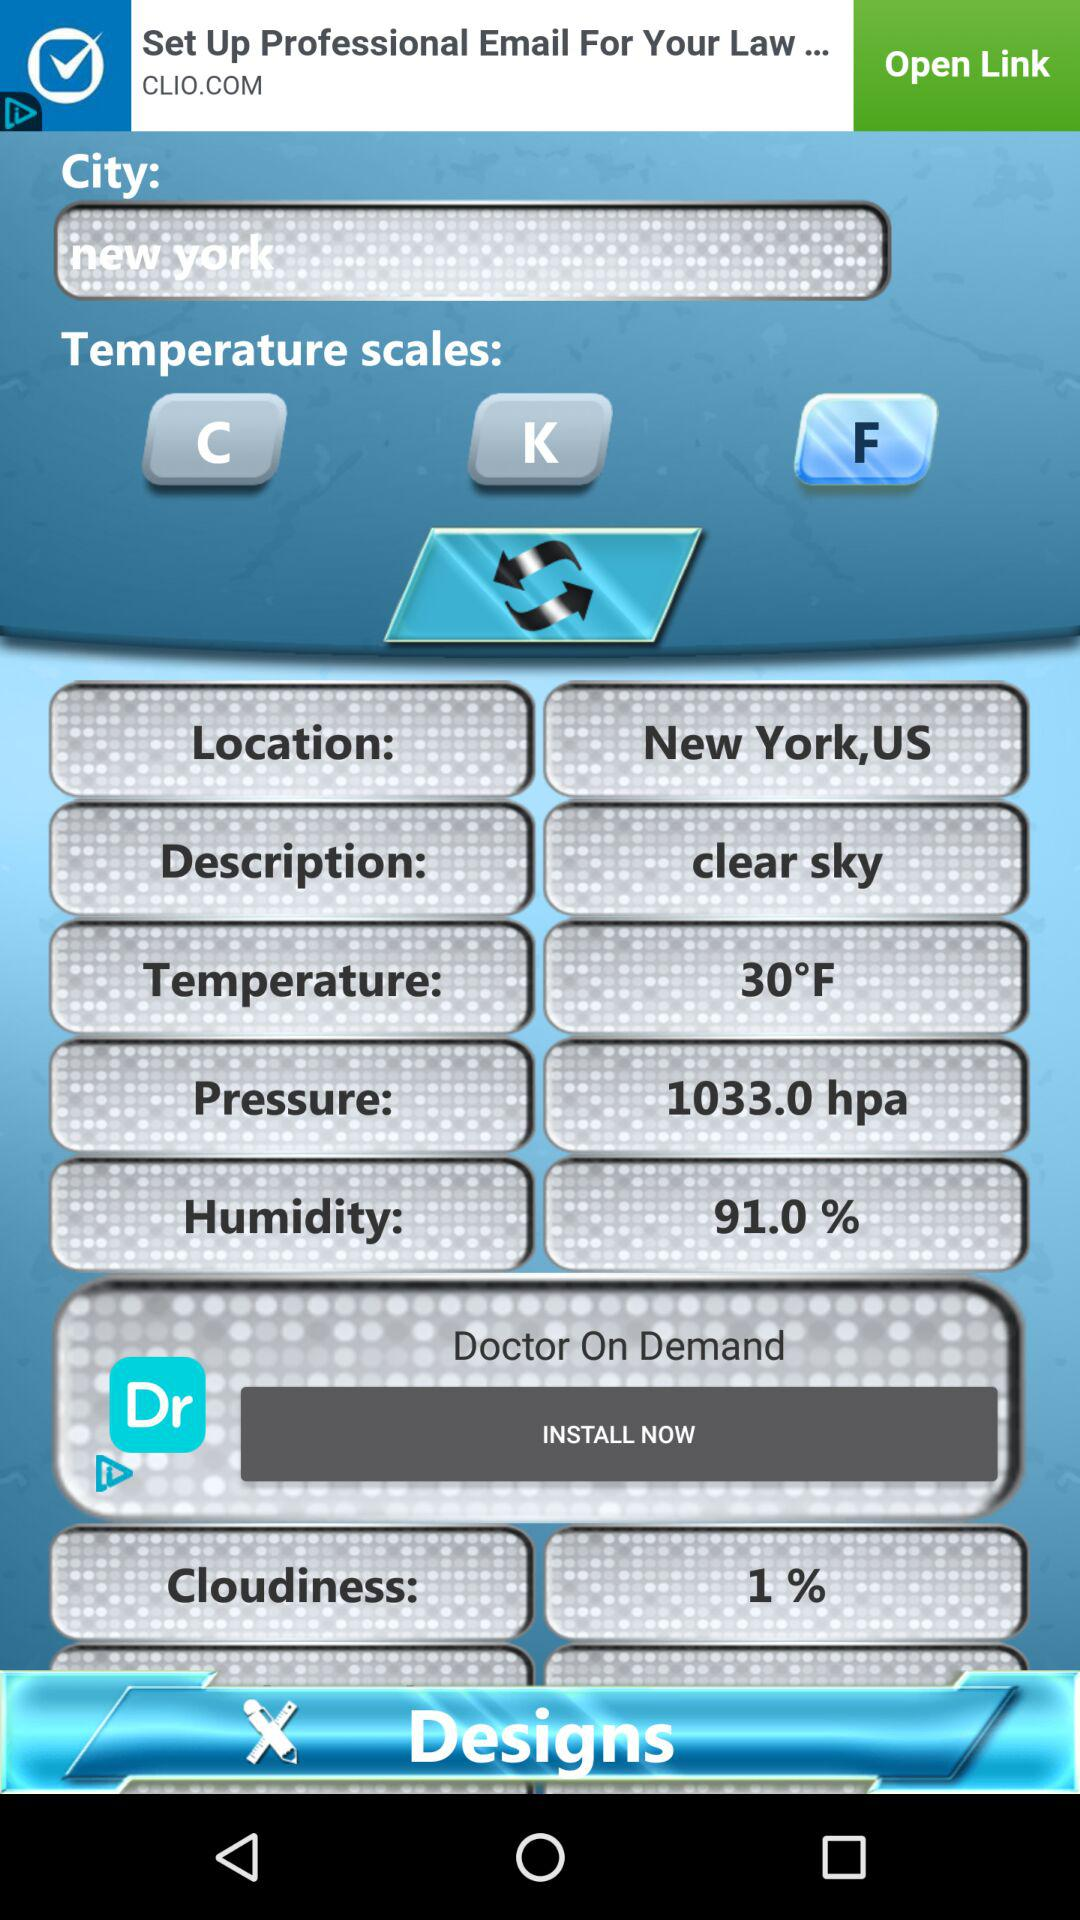What is the percentage of humidity in New York? The percentage is 91. 